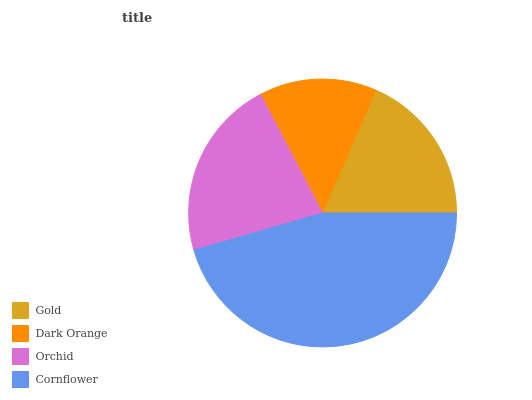Is Dark Orange the minimum?
Answer yes or no. Yes. Is Cornflower the maximum?
Answer yes or no. Yes. Is Orchid the minimum?
Answer yes or no. No. Is Orchid the maximum?
Answer yes or no. No. Is Orchid greater than Dark Orange?
Answer yes or no. Yes. Is Dark Orange less than Orchid?
Answer yes or no. Yes. Is Dark Orange greater than Orchid?
Answer yes or no. No. Is Orchid less than Dark Orange?
Answer yes or no. No. Is Orchid the high median?
Answer yes or no. Yes. Is Gold the low median?
Answer yes or no. Yes. Is Gold the high median?
Answer yes or no. No. Is Orchid the low median?
Answer yes or no. No. 